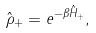<formula> <loc_0><loc_0><loc_500><loc_500>\hat { \rho } _ { + } = e ^ { - \beta \hat { H } _ { + } } ,</formula> 